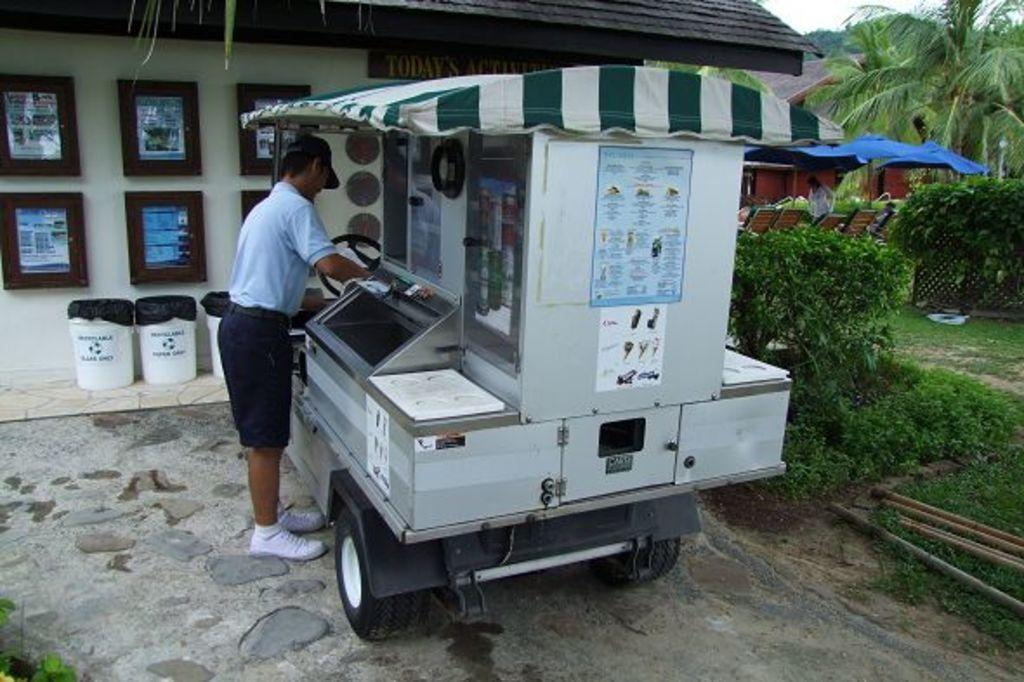What is the person holding in the image? The person is holding something in the image, but the facts do not specify what it is. What type of vehicle is in the image? The facts do not specify the type of vehicle in the image. What are the dustbins used for in the image? The dustbins are present in the image, but their purpose is not specified. What is attached to the wall in the image? There are frames attached to the wall in the image. What type of vegetation is visible in the image? Trees are visible in the image. What type of temporary shelter is present in the image? Tents are present in the image. What type of structures are visible in the image? Buildings are visible in the image. What type of jeans is the expert wearing in the image? There is no expert or jeans present in the image. What attempt is the person making in the image? The facts do not specify any attempt being made by the person in the image. 